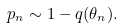Convert formula to latex. <formula><loc_0><loc_0><loc_500><loc_500>p _ { n } \sim 1 - q ( \theta _ { n } ) .</formula> 